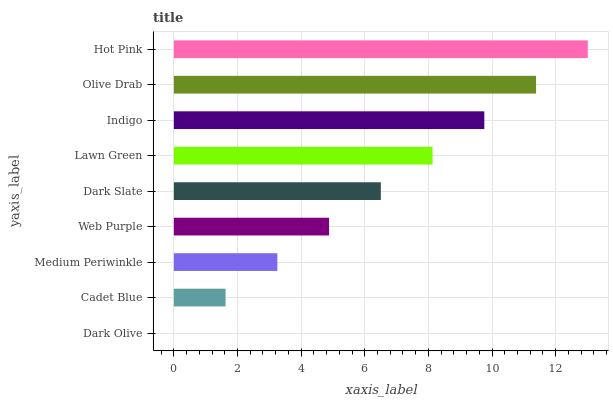Is Dark Olive the minimum?
Answer yes or no. Yes. Is Hot Pink the maximum?
Answer yes or no. Yes. Is Cadet Blue the minimum?
Answer yes or no. No. Is Cadet Blue the maximum?
Answer yes or no. No. Is Cadet Blue greater than Dark Olive?
Answer yes or no. Yes. Is Dark Olive less than Cadet Blue?
Answer yes or no. Yes. Is Dark Olive greater than Cadet Blue?
Answer yes or no. No. Is Cadet Blue less than Dark Olive?
Answer yes or no. No. Is Dark Slate the high median?
Answer yes or no. Yes. Is Dark Slate the low median?
Answer yes or no. Yes. Is Indigo the high median?
Answer yes or no. No. Is Web Purple the low median?
Answer yes or no. No. 